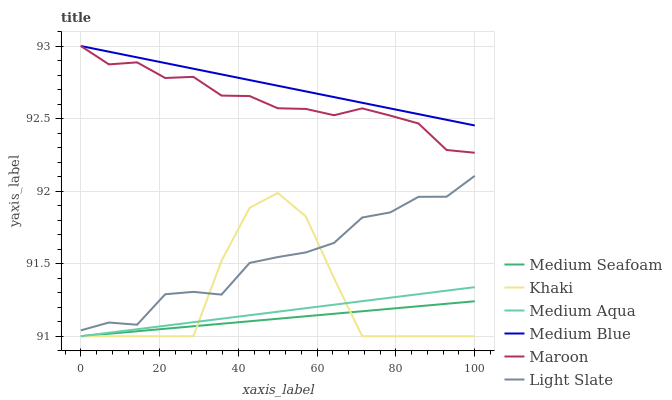Does Medium Seafoam have the minimum area under the curve?
Answer yes or no. Yes. Does Medium Blue have the maximum area under the curve?
Answer yes or no. Yes. Does Light Slate have the minimum area under the curve?
Answer yes or no. No. Does Light Slate have the maximum area under the curve?
Answer yes or no. No. Is Medium Seafoam the smoothest?
Answer yes or no. Yes. Is Khaki the roughest?
Answer yes or no. Yes. Is Light Slate the smoothest?
Answer yes or no. No. Is Light Slate the roughest?
Answer yes or no. No. Does Khaki have the lowest value?
Answer yes or no. Yes. Does Light Slate have the lowest value?
Answer yes or no. No. Does Maroon have the highest value?
Answer yes or no. Yes. Does Light Slate have the highest value?
Answer yes or no. No. Is Medium Seafoam less than Light Slate?
Answer yes or no. Yes. Is Light Slate greater than Medium Seafoam?
Answer yes or no. Yes. Does Khaki intersect Medium Aqua?
Answer yes or no. Yes. Is Khaki less than Medium Aqua?
Answer yes or no. No. Is Khaki greater than Medium Aqua?
Answer yes or no. No. Does Medium Seafoam intersect Light Slate?
Answer yes or no. No. 